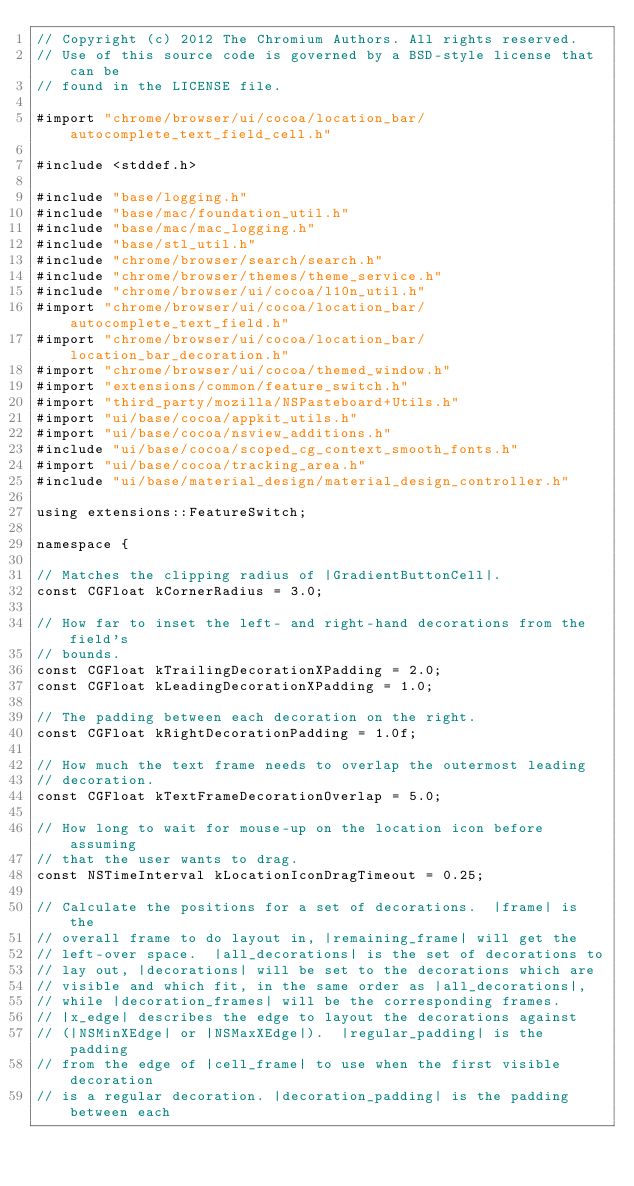<code> <loc_0><loc_0><loc_500><loc_500><_ObjectiveC_>// Copyright (c) 2012 The Chromium Authors. All rights reserved.
// Use of this source code is governed by a BSD-style license that can be
// found in the LICENSE file.

#import "chrome/browser/ui/cocoa/location_bar/autocomplete_text_field_cell.h"

#include <stddef.h>

#include "base/logging.h"
#include "base/mac/foundation_util.h"
#include "base/mac/mac_logging.h"
#include "base/stl_util.h"
#include "chrome/browser/search/search.h"
#include "chrome/browser/themes/theme_service.h"
#include "chrome/browser/ui/cocoa/l10n_util.h"
#import "chrome/browser/ui/cocoa/location_bar/autocomplete_text_field.h"
#import "chrome/browser/ui/cocoa/location_bar/location_bar_decoration.h"
#import "chrome/browser/ui/cocoa/themed_window.h"
#import "extensions/common/feature_switch.h"
#import "third_party/mozilla/NSPasteboard+Utils.h"
#import "ui/base/cocoa/appkit_utils.h"
#import "ui/base/cocoa/nsview_additions.h"
#include "ui/base/cocoa/scoped_cg_context_smooth_fonts.h"
#import "ui/base/cocoa/tracking_area.h"
#include "ui/base/material_design/material_design_controller.h"

using extensions::FeatureSwitch;

namespace {

// Matches the clipping radius of |GradientButtonCell|.
const CGFloat kCornerRadius = 3.0;

// How far to inset the left- and right-hand decorations from the field's
// bounds.
const CGFloat kTrailingDecorationXPadding = 2.0;
const CGFloat kLeadingDecorationXPadding = 1.0;

// The padding between each decoration on the right.
const CGFloat kRightDecorationPadding = 1.0f;

// How much the text frame needs to overlap the outermost leading
// decoration.
const CGFloat kTextFrameDecorationOverlap = 5.0;

// How long to wait for mouse-up on the location icon before assuming
// that the user wants to drag.
const NSTimeInterval kLocationIconDragTimeout = 0.25;

// Calculate the positions for a set of decorations.  |frame| is the
// overall frame to do layout in, |remaining_frame| will get the
// left-over space.  |all_decorations| is the set of decorations to
// lay out, |decorations| will be set to the decorations which are
// visible and which fit, in the same order as |all_decorations|,
// while |decoration_frames| will be the corresponding frames.
// |x_edge| describes the edge to layout the decorations against
// (|NSMinXEdge| or |NSMaxXEdge|).  |regular_padding| is the padding
// from the edge of |cell_frame| to use when the first visible decoration
// is a regular decoration. |decoration_padding| is the padding between each</code> 